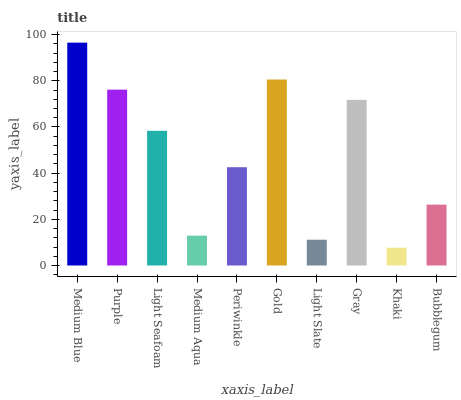Is Khaki the minimum?
Answer yes or no. Yes. Is Medium Blue the maximum?
Answer yes or no. Yes. Is Purple the minimum?
Answer yes or no. No. Is Purple the maximum?
Answer yes or no. No. Is Medium Blue greater than Purple?
Answer yes or no. Yes. Is Purple less than Medium Blue?
Answer yes or no. Yes. Is Purple greater than Medium Blue?
Answer yes or no. No. Is Medium Blue less than Purple?
Answer yes or no. No. Is Light Seafoam the high median?
Answer yes or no. Yes. Is Periwinkle the low median?
Answer yes or no. Yes. Is Gray the high median?
Answer yes or no. No. Is Gray the low median?
Answer yes or no. No. 